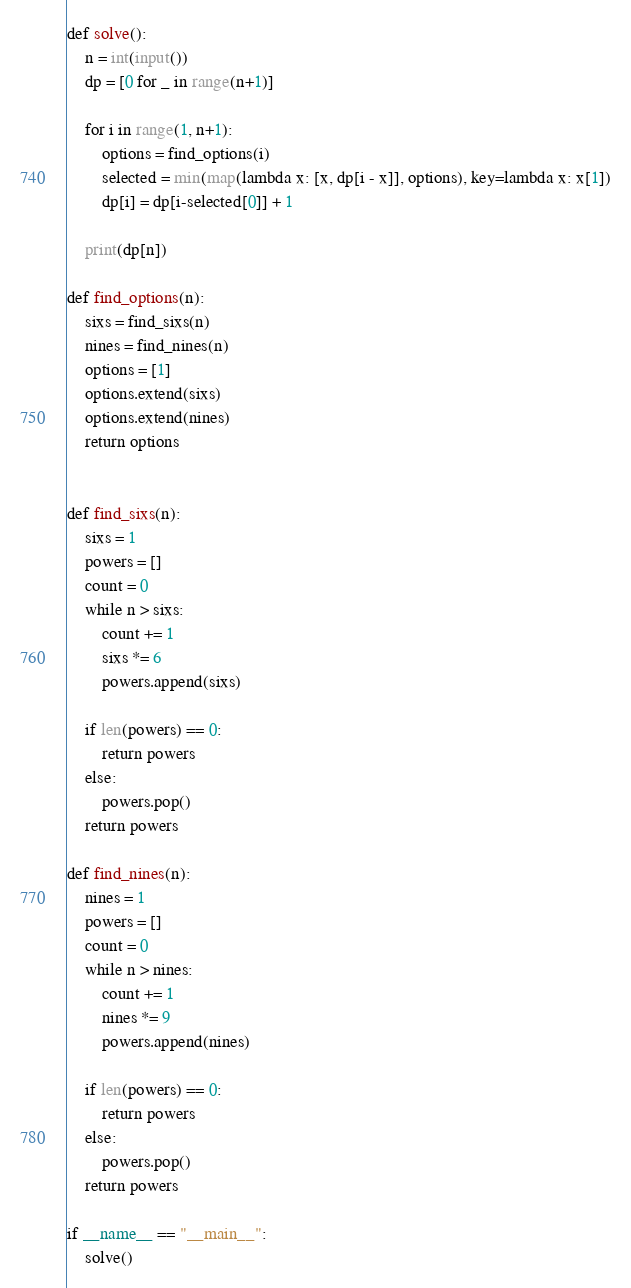Convert code to text. <code><loc_0><loc_0><loc_500><loc_500><_Python_>def solve():
    n = int(input())
    dp = [0 for _ in range(n+1)] 

    for i in range(1, n+1):
        options = find_options(i)
        selected = min(map(lambda x: [x, dp[i - x]], options), key=lambda x: x[1])
        dp[i] = dp[i-selected[0]] + 1

    print(dp[n])

def find_options(n):
    sixs = find_sixs(n)
    nines = find_nines(n)
    options = [1]
    options.extend(sixs)
    options.extend(nines)
    return options


def find_sixs(n):
    sixs = 1
    powers = [] 
    count = 0
    while n > sixs:
        count += 1
        sixs *= 6
        powers.append(sixs)
    
    if len(powers) == 0:
        return powers
    else:
        powers.pop()
    return powers

def find_nines(n):
    nines = 1
    powers = [] 
    count = 0
    while n > nines:
        count += 1
        nines *= 9
        powers.append(nines)
    
    if len(powers) == 0:
        return powers
    else:
        powers.pop()
    return powers

if __name__ == "__main__":
    solve()</code> 